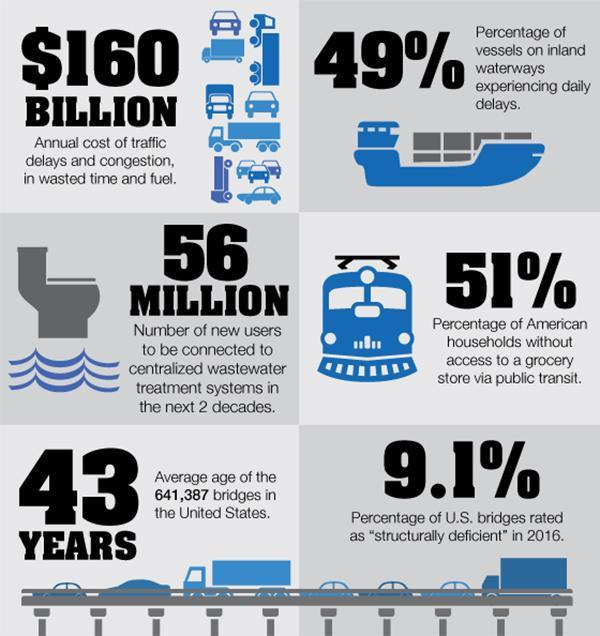What is the percentage of American households with access to a grocery store via public transit?
Answer the question with a short phrase. 49% What is the annual cost of traffic delays and congestion, in wasted time and fuel? $160 billion 